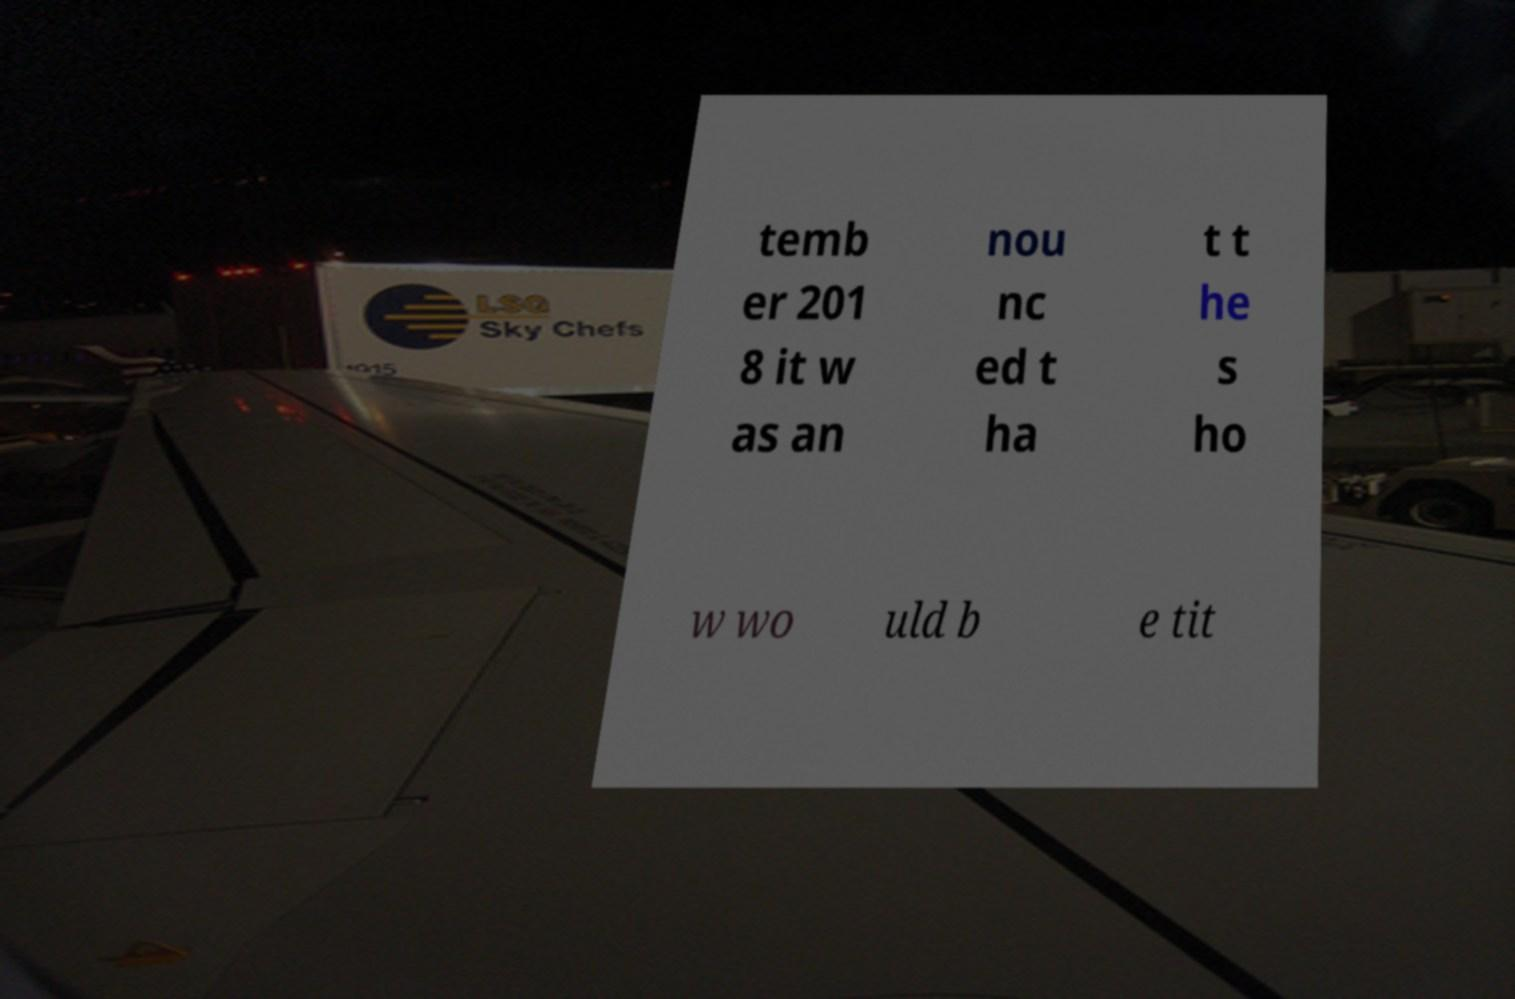I need the written content from this picture converted into text. Can you do that? temb er 201 8 it w as an nou nc ed t ha t t he s ho w wo uld b e tit 